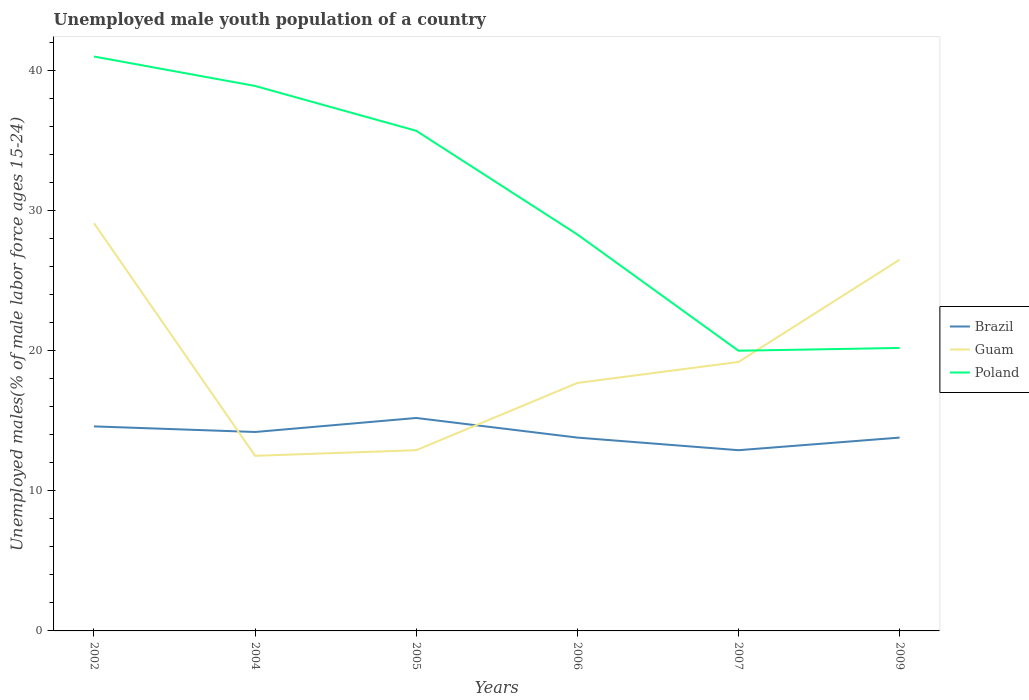Is the number of lines equal to the number of legend labels?
Give a very brief answer. Yes. Across all years, what is the maximum percentage of unemployed male youth population in Poland?
Make the answer very short. 20. What is the total percentage of unemployed male youth population in Poland in the graph?
Your answer should be compact. 20.8. What is the difference between the highest and the second highest percentage of unemployed male youth population in Brazil?
Ensure brevity in your answer.  2.3. What is the difference between the highest and the lowest percentage of unemployed male youth population in Guam?
Ensure brevity in your answer.  2. Is the percentage of unemployed male youth population in Guam strictly greater than the percentage of unemployed male youth population in Brazil over the years?
Offer a terse response. No. How many years are there in the graph?
Provide a succinct answer. 6. What is the difference between two consecutive major ticks on the Y-axis?
Offer a terse response. 10. Does the graph contain any zero values?
Your answer should be very brief. No. How are the legend labels stacked?
Keep it short and to the point. Vertical. What is the title of the graph?
Your answer should be very brief. Unemployed male youth population of a country. What is the label or title of the Y-axis?
Give a very brief answer. Unemployed males(% of male labor force ages 15-24). What is the Unemployed males(% of male labor force ages 15-24) in Brazil in 2002?
Your answer should be compact. 14.6. What is the Unemployed males(% of male labor force ages 15-24) in Guam in 2002?
Your answer should be very brief. 29.1. What is the Unemployed males(% of male labor force ages 15-24) of Brazil in 2004?
Offer a terse response. 14.2. What is the Unemployed males(% of male labor force ages 15-24) in Guam in 2004?
Provide a short and direct response. 12.5. What is the Unemployed males(% of male labor force ages 15-24) in Poland in 2004?
Keep it short and to the point. 38.9. What is the Unemployed males(% of male labor force ages 15-24) in Brazil in 2005?
Make the answer very short. 15.2. What is the Unemployed males(% of male labor force ages 15-24) of Guam in 2005?
Provide a succinct answer. 12.9. What is the Unemployed males(% of male labor force ages 15-24) in Poland in 2005?
Your response must be concise. 35.7. What is the Unemployed males(% of male labor force ages 15-24) in Brazil in 2006?
Keep it short and to the point. 13.8. What is the Unemployed males(% of male labor force ages 15-24) of Guam in 2006?
Your response must be concise. 17.7. What is the Unemployed males(% of male labor force ages 15-24) in Poland in 2006?
Your response must be concise. 28.3. What is the Unemployed males(% of male labor force ages 15-24) of Brazil in 2007?
Give a very brief answer. 12.9. What is the Unemployed males(% of male labor force ages 15-24) of Guam in 2007?
Your answer should be very brief. 19.2. What is the Unemployed males(% of male labor force ages 15-24) of Poland in 2007?
Ensure brevity in your answer.  20. What is the Unemployed males(% of male labor force ages 15-24) in Brazil in 2009?
Your response must be concise. 13.8. What is the Unemployed males(% of male labor force ages 15-24) of Poland in 2009?
Make the answer very short. 20.2. Across all years, what is the maximum Unemployed males(% of male labor force ages 15-24) of Brazil?
Keep it short and to the point. 15.2. Across all years, what is the maximum Unemployed males(% of male labor force ages 15-24) in Guam?
Keep it short and to the point. 29.1. Across all years, what is the minimum Unemployed males(% of male labor force ages 15-24) in Brazil?
Your response must be concise. 12.9. Across all years, what is the minimum Unemployed males(% of male labor force ages 15-24) of Guam?
Your response must be concise. 12.5. Across all years, what is the minimum Unemployed males(% of male labor force ages 15-24) of Poland?
Make the answer very short. 20. What is the total Unemployed males(% of male labor force ages 15-24) of Brazil in the graph?
Provide a succinct answer. 84.5. What is the total Unemployed males(% of male labor force ages 15-24) of Guam in the graph?
Provide a short and direct response. 117.9. What is the total Unemployed males(% of male labor force ages 15-24) of Poland in the graph?
Your answer should be compact. 184.1. What is the difference between the Unemployed males(% of male labor force ages 15-24) of Brazil in 2002 and that in 2004?
Provide a short and direct response. 0.4. What is the difference between the Unemployed males(% of male labor force ages 15-24) of Poland in 2002 and that in 2004?
Your response must be concise. 2.1. What is the difference between the Unemployed males(% of male labor force ages 15-24) of Brazil in 2002 and that in 2005?
Ensure brevity in your answer.  -0.6. What is the difference between the Unemployed males(% of male labor force ages 15-24) in Poland in 2002 and that in 2005?
Your answer should be very brief. 5.3. What is the difference between the Unemployed males(% of male labor force ages 15-24) in Brazil in 2002 and that in 2006?
Make the answer very short. 0.8. What is the difference between the Unemployed males(% of male labor force ages 15-24) in Guam in 2002 and that in 2006?
Provide a short and direct response. 11.4. What is the difference between the Unemployed males(% of male labor force ages 15-24) in Poland in 2002 and that in 2006?
Your response must be concise. 12.7. What is the difference between the Unemployed males(% of male labor force ages 15-24) in Brazil in 2002 and that in 2007?
Provide a succinct answer. 1.7. What is the difference between the Unemployed males(% of male labor force ages 15-24) in Guam in 2002 and that in 2007?
Provide a succinct answer. 9.9. What is the difference between the Unemployed males(% of male labor force ages 15-24) in Brazil in 2002 and that in 2009?
Your response must be concise. 0.8. What is the difference between the Unemployed males(% of male labor force ages 15-24) in Poland in 2002 and that in 2009?
Provide a short and direct response. 20.8. What is the difference between the Unemployed males(% of male labor force ages 15-24) in Brazil in 2004 and that in 2005?
Keep it short and to the point. -1. What is the difference between the Unemployed males(% of male labor force ages 15-24) in Guam in 2004 and that in 2005?
Your answer should be very brief. -0.4. What is the difference between the Unemployed males(% of male labor force ages 15-24) of Poland in 2004 and that in 2005?
Give a very brief answer. 3.2. What is the difference between the Unemployed males(% of male labor force ages 15-24) in Brazil in 2004 and that in 2006?
Your answer should be very brief. 0.4. What is the difference between the Unemployed males(% of male labor force ages 15-24) in Guam in 2004 and that in 2006?
Provide a succinct answer. -5.2. What is the difference between the Unemployed males(% of male labor force ages 15-24) in Poland in 2004 and that in 2006?
Give a very brief answer. 10.6. What is the difference between the Unemployed males(% of male labor force ages 15-24) of Guam in 2004 and that in 2007?
Offer a terse response. -6.7. What is the difference between the Unemployed males(% of male labor force ages 15-24) in Poland in 2004 and that in 2007?
Keep it short and to the point. 18.9. What is the difference between the Unemployed males(% of male labor force ages 15-24) in Brazil in 2004 and that in 2009?
Make the answer very short. 0.4. What is the difference between the Unemployed males(% of male labor force ages 15-24) of Poland in 2004 and that in 2009?
Your answer should be very brief. 18.7. What is the difference between the Unemployed males(% of male labor force ages 15-24) in Brazil in 2005 and that in 2007?
Offer a very short reply. 2.3. What is the difference between the Unemployed males(% of male labor force ages 15-24) in Guam in 2005 and that in 2007?
Provide a short and direct response. -6.3. What is the difference between the Unemployed males(% of male labor force ages 15-24) of Poland in 2005 and that in 2007?
Provide a short and direct response. 15.7. What is the difference between the Unemployed males(% of male labor force ages 15-24) in Brazil in 2005 and that in 2009?
Offer a very short reply. 1.4. What is the difference between the Unemployed males(% of male labor force ages 15-24) of Guam in 2005 and that in 2009?
Your answer should be compact. -13.6. What is the difference between the Unemployed males(% of male labor force ages 15-24) in Poland in 2005 and that in 2009?
Ensure brevity in your answer.  15.5. What is the difference between the Unemployed males(% of male labor force ages 15-24) in Guam in 2006 and that in 2007?
Make the answer very short. -1.5. What is the difference between the Unemployed males(% of male labor force ages 15-24) of Brazil in 2006 and that in 2009?
Offer a terse response. 0. What is the difference between the Unemployed males(% of male labor force ages 15-24) of Guam in 2006 and that in 2009?
Your answer should be very brief. -8.8. What is the difference between the Unemployed males(% of male labor force ages 15-24) of Brazil in 2007 and that in 2009?
Your answer should be compact. -0.9. What is the difference between the Unemployed males(% of male labor force ages 15-24) in Brazil in 2002 and the Unemployed males(% of male labor force ages 15-24) in Poland in 2004?
Give a very brief answer. -24.3. What is the difference between the Unemployed males(% of male labor force ages 15-24) of Brazil in 2002 and the Unemployed males(% of male labor force ages 15-24) of Guam in 2005?
Your answer should be compact. 1.7. What is the difference between the Unemployed males(% of male labor force ages 15-24) of Brazil in 2002 and the Unemployed males(% of male labor force ages 15-24) of Poland in 2005?
Ensure brevity in your answer.  -21.1. What is the difference between the Unemployed males(% of male labor force ages 15-24) in Brazil in 2002 and the Unemployed males(% of male labor force ages 15-24) in Guam in 2006?
Provide a succinct answer. -3.1. What is the difference between the Unemployed males(% of male labor force ages 15-24) in Brazil in 2002 and the Unemployed males(% of male labor force ages 15-24) in Poland in 2006?
Your answer should be very brief. -13.7. What is the difference between the Unemployed males(% of male labor force ages 15-24) of Guam in 2002 and the Unemployed males(% of male labor force ages 15-24) of Poland in 2006?
Offer a terse response. 0.8. What is the difference between the Unemployed males(% of male labor force ages 15-24) in Brazil in 2002 and the Unemployed males(% of male labor force ages 15-24) in Poland in 2007?
Provide a succinct answer. -5.4. What is the difference between the Unemployed males(% of male labor force ages 15-24) in Brazil in 2002 and the Unemployed males(% of male labor force ages 15-24) in Poland in 2009?
Offer a very short reply. -5.6. What is the difference between the Unemployed males(% of male labor force ages 15-24) of Guam in 2002 and the Unemployed males(% of male labor force ages 15-24) of Poland in 2009?
Your answer should be very brief. 8.9. What is the difference between the Unemployed males(% of male labor force ages 15-24) in Brazil in 2004 and the Unemployed males(% of male labor force ages 15-24) in Poland in 2005?
Offer a very short reply. -21.5. What is the difference between the Unemployed males(% of male labor force ages 15-24) of Guam in 2004 and the Unemployed males(% of male labor force ages 15-24) of Poland in 2005?
Your answer should be compact. -23.2. What is the difference between the Unemployed males(% of male labor force ages 15-24) of Brazil in 2004 and the Unemployed males(% of male labor force ages 15-24) of Poland in 2006?
Provide a succinct answer. -14.1. What is the difference between the Unemployed males(% of male labor force ages 15-24) of Guam in 2004 and the Unemployed males(% of male labor force ages 15-24) of Poland in 2006?
Provide a succinct answer. -15.8. What is the difference between the Unemployed males(% of male labor force ages 15-24) in Brazil in 2004 and the Unemployed males(% of male labor force ages 15-24) in Poland in 2007?
Your response must be concise. -5.8. What is the difference between the Unemployed males(% of male labor force ages 15-24) of Guam in 2004 and the Unemployed males(% of male labor force ages 15-24) of Poland in 2007?
Offer a very short reply. -7.5. What is the difference between the Unemployed males(% of male labor force ages 15-24) of Brazil in 2004 and the Unemployed males(% of male labor force ages 15-24) of Guam in 2009?
Offer a very short reply. -12.3. What is the difference between the Unemployed males(% of male labor force ages 15-24) in Brazil in 2004 and the Unemployed males(% of male labor force ages 15-24) in Poland in 2009?
Give a very brief answer. -6. What is the difference between the Unemployed males(% of male labor force ages 15-24) in Guam in 2004 and the Unemployed males(% of male labor force ages 15-24) in Poland in 2009?
Offer a terse response. -7.7. What is the difference between the Unemployed males(% of male labor force ages 15-24) of Guam in 2005 and the Unemployed males(% of male labor force ages 15-24) of Poland in 2006?
Ensure brevity in your answer.  -15.4. What is the difference between the Unemployed males(% of male labor force ages 15-24) of Brazil in 2005 and the Unemployed males(% of male labor force ages 15-24) of Guam in 2007?
Provide a short and direct response. -4. What is the difference between the Unemployed males(% of male labor force ages 15-24) of Guam in 2005 and the Unemployed males(% of male labor force ages 15-24) of Poland in 2007?
Your response must be concise. -7.1. What is the difference between the Unemployed males(% of male labor force ages 15-24) in Brazil in 2005 and the Unemployed males(% of male labor force ages 15-24) in Poland in 2009?
Give a very brief answer. -5. What is the difference between the Unemployed males(% of male labor force ages 15-24) in Brazil in 2006 and the Unemployed males(% of male labor force ages 15-24) in Poland in 2007?
Provide a short and direct response. -6.2. What is the difference between the Unemployed males(% of male labor force ages 15-24) of Guam in 2006 and the Unemployed males(% of male labor force ages 15-24) of Poland in 2007?
Offer a terse response. -2.3. What is the difference between the Unemployed males(% of male labor force ages 15-24) in Brazil in 2006 and the Unemployed males(% of male labor force ages 15-24) in Poland in 2009?
Give a very brief answer. -6.4. What is the difference between the Unemployed males(% of male labor force ages 15-24) in Guam in 2006 and the Unemployed males(% of male labor force ages 15-24) in Poland in 2009?
Offer a very short reply. -2.5. What is the difference between the Unemployed males(% of male labor force ages 15-24) of Brazil in 2007 and the Unemployed males(% of male labor force ages 15-24) of Guam in 2009?
Provide a succinct answer. -13.6. What is the average Unemployed males(% of male labor force ages 15-24) of Brazil per year?
Ensure brevity in your answer.  14.08. What is the average Unemployed males(% of male labor force ages 15-24) of Guam per year?
Provide a short and direct response. 19.65. What is the average Unemployed males(% of male labor force ages 15-24) in Poland per year?
Your response must be concise. 30.68. In the year 2002, what is the difference between the Unemployed males(% of male labor force ages 15-24) of Brazil and Unemployed males(% of male labor force ages 15-24) of Poland?
Your answer should be very brief. -26.4. In the year 2002, what is the difference between the Unemployed males(% of male labor force ages 15-24) in Guam and Unemployed males(% of male labor force ages 15-24) in Poland?
Provide a succinct answer. -11.9. In the year 2004, what is the difference between the Unemployed males(% of male labor force ages 15-24) in Brazil and Unemployed males(% of male labor force ages 15-24) in Poland?
Your answer should be compact. -24.7. In the year 2004, what is the difference between the Unemployed males(% of male labor force ages 15-24) in Guam and Unemployed males(% of male labor force ages 15-24) in Poland?
Ensure brevity in your answer.  -26.4. In the year 2005, what is the difference between the Unemployed males(% of male labor force ages 15-24) in Brazil and Unemployed males(% of male labor force ages 15-24) in Guam?
Your answer should be very brief. 2.3. In the year 2005, what is the difference between the Unemployed males(% of male labor force ages 15-24) in Brazil and Unemployed males(% of male labor force ages 15-24) in Poland?
Your answer should be compact. -20.5. In the year 2005, what is the difference between the Unemployed males(% of male labor force ages 15-24) in Guam and Unemployed males(% of male labor force ages 15-24) in Poland?
Keep it short and to the point. -22.8. In the year 2007, what is the difference between the Unemployed males(% of male labor force ages 15-24) of Brazil and Unemployed males(% of male labor force ages 15-24) of Guam?
Offer a very short reply. -6.3. In the year 2007, what is the difference between the Unemployed males(% of male labor force ages 15-24) of Brazil and Unemployed males(% of male labor force ages 15-24) of Poland?
Provide a succinct answer. -7.1. In the year 2007, what is the difference between the Unemployed males(% of male labor force ages 15-24) in Guam and Unemployed males(% of male labor force ages 15-24) in Poland?
Keep it short and to the point. -0.8. In the year 2009, what is the difference between the Unemployed males(% of male labor force ages 15-24) of Brazil and Unemployed males(% of male labor force ages 15-24) of Guam?
Make the answer very short. -12.7. In the year 2009, what is the difference between the Unemployed males(% of male labor force ages 15-24) of Brazil and Unemployed males(% of male labor force ages 15-24) of Poland?
Offer a very short reply. -6.4. What is the ratio of the Unemployed males(% of male labor force ages 15-24) of Brazil in 2002 to that in 2004?
Provide a short and direct response. 1.03. What is the ratio of the Unemployed males(% of male labor force ages 15-24) of Guam in 2002 to that in 2004?
Your response must be concise. 2.33. What is the ratio of the Unemployed males(% of male labor force ages 15-24) of Poland in 2002 to that in 2004?
Give a very brief answer. 1.05. What is the ratio of the Unemployed males(% of male labor force ages 15-24) in Brazil in 2002 to that in 2005?
Make the answer very short. 0.96. What is the ratio of the Unemployed males(% of male labor force ages 15-24) of Guam in 2002 to that in 2005?
Provide a succinct answer. 2.26. What is the ratio of the Unemployed males(% of male labor force ages 15-24) of Poland in 2002 to that in 2005?
Your response must be concise. 1.15. What is the ratio of the Unemployed males(% of male labor force ages 15-24) of Brazil in 2002 to that in 2006?
Offer a terse response. 1.06. What is the ratio of the Unemployed males(% of male labor force ages 15-24) of Guam in 2002 to that in 2006?
Keep it short and to the point. 1.64. What is the ratio of the Unemployed males(% of male labor force ages 15-24) of Poland in 2002 to that in 2006?
Provide a short and direct response. 1.45. What is the ratio of the Unemployed males(% of male labor force ages 15-24) in Brazil in 2002 to that in 2007?
Offer a terse response. 1.13. What is the ratio of the Unemployed males(% of male labor force ages 15-24) of Guam in 2002 to that in 2007?
Offer a terse response. 1.52. What is the ratio of the Unemployed males(% of male labor force ages 15-24) in Poland in 2002 to that in 2007?
Keep it short and to the point. 2.05. What is the ratio of the Unemployed males(% of male labor force ages 15-24) of Brazil in 2002 to that in 2009?
Provide a short and direct response. 1.06. What is the ratio of the Unemployed males(% of male labor force ages 15-24) in Guam in 2002 to that in 2009?
Give a very brief answer. 1.1. What is the ratio of the Unemployed males(% of male labor force ages 15-24) in Poland in 2002 to that in 2009?
Keep it short and to the point. 2.03. What is the ratio of the Unemployed males(% of male labor force ages 15-24) of Brazil in 2004 to that in 2005?
Your response must be concise. 0.93. What is the ratio of the Unemployed males(% of male labor force ages 15-24) in Poland in 2004 to that in 2005?
Provide a short and direct response. 1.09. What is the ratio of the Unemployed males(% of male labor force ages 15-24) in Brazil in 2004 to that in 2006?
Ensure brevity in your answer.  1.03. What is the ratio of the Unemployed males(% of male labor force ages 15-24) in Guam in 2004 to that in 2006?
Ensure brevity in your answer.  0.71. What is the ratio of the Unemployed males(% of male labor force ages 15-24) in Poland in 2004 to that in 2006?
Ensure brevity in your answer.  1.37. What is the ratio of the Unemployed males(% of male labor force ages 15-24) in Brazil in 2004 to that in 2007?
Your answer should be very brief. 1.1. What is the ratio of the Unemployed males(% of male labor force ages 15-24) of Guam in 2004 to that in 2007?
Offer a terse response. 0.65. What is the ratio of the Unemployed males(% of male labor force ages 15-24) in Poland in 2004 to that in 2007?
Offer a terse response. 1.95. What is the ratio of the Unemployed males(% of male labor force ages 15-24) of Brazil in 2004 to that in 2009?
Offer a very short reply. 1.03. What is the ratio of the Unemployed males(% of male labor force ages 15-24) of Guam in 2004 to that in 2009?
Your response must be concise. 0.47. What is the ratio of the Unemployed males(% of male labor force ages 15-24) in Poland in 2004 to that in 2009?
Make the answer very short. 1.93. What is the ratio of the Unemployed males(% of male labor force ages 15-24) of Brazil in 2005 to that in 2006?
Make the answer very short. 1.1. What is the ratio of the Unemployed males(% of male labor force ages 15-24) of Guam in 2005 to that in 2006?
Provide a short and direct response. 0.73. What is the ratio of the Unemployed males(% of male labor force ages 15-24) of Poland in 2005 to that in 2006?
Your answer should be very brief. 1.26. What is the ratio of the Unemployed males(% of male labor force ages 15-24) in Brazil in 2005 to that in 2007?
Offer a terse response. 1.18. What is the ratio of the Unemployed males(% of male labor force ages 15-24) in Guam in 2005 to that in 2007?
Make the answer very short. 0.67. What is the ratio of the Unemployed males(% of male labor force ages 15-24) of Poland in 2005 to that in 2007?
Offer a very short reply. 1.78. What is the ratio of the Unemployed males(% of male labor force ages 15-24) in Brazil in 2005 to that in 2009?
Keep it short and to the point. 1.1. What is the ratio of the Unemployed males(% of male labor force ages 15-24) in Guam in 2005 to that in 2009?
Offer a very short reply. 0.49. What is the ratio of the Unemployed males(% of male labor force ages 15-24) of Poland in 2005 to that in 2009?
Make the answer very short. 1.77. What is the ratio of the Unemployed males(% of male labor force ages 15-24) of Brazil in 2006 to that in 2007?
Keep it short and to the point. 1.07. What is the ratio of the Unemployed males(% of male labor force ages 15-24) in Guam in 2006 to that in 2007?
Your answer should be compact. 0.92. What is the ratio of the Unemployed males(% of male labor force ages 15-24) in Poland in 2006 to that in 2007?
Offer a terse response. 1.42. What is the ratio of the Unemployed males(% of male labor force ages 15-24) in Brazil in 2006 to that in 2009?
Your answer should be very brief. 1. What is the ratio of the Unemployed males(% of male labor force ages 15-24) of Guam in 2006 to that in 2009?
Your answer should be very brief. 0.67. What is the ratio of the Unemployed males(% of male labor force ages 15-24) in Poland in 2006 to that in 2009?
Ensure brevity in your answer.  1.4. What is the ratio of the Unemployed males(% of male labor force ages 15-24) of Brazil in 2007 to that in 2009?
Your answer should be very brief. 0.93. What is the ratio of the Unemployed males(% of male labor force ages 15-24) of Guam in 2007 to that in 2009?
Keep it short and to the point. 0.72. What is the difference between the highest and the second highest Unemployed males(% of male labor force ages 15-24) in Brazil?
Keep it short and to the point. 0.6. What is the difference between the highest and the second highest Unemployed males(% of male labor force ages 15-24) in Poland?
Give a very brief answer. 2.1. What is the difference between the highest and the lowest Unemployed males(% of male labor force ages 15-24) of Guam?
Ensure brevity in your answer.  16.6. 